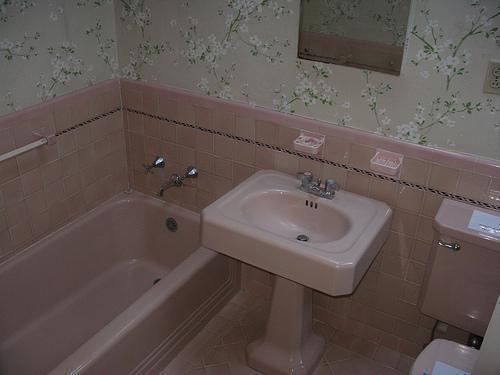How many soap dishes are on the wall?
Give a very brief answer. 1. How many taps are in the sink?
Give a very brief answer. 2. 